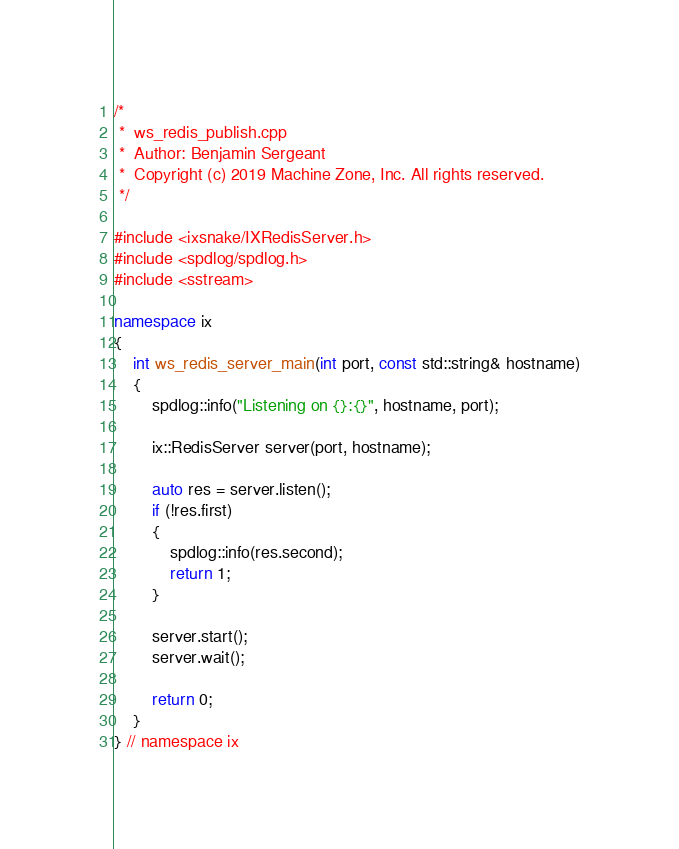<code> <loc_0><loc_0><loc_500><loc_500><_C++_>/*
 *  ws_redis_publish.cpp
 *  Author: Benjamin Sergeant
 *  Copyright (c) 2019 Machine Zone, Inc. All rights reserved.
 */

#include <ixsnake/IXRedisServer.h>
#include <spdlog/spdlog.h>
#include <sstream>

namespace ix
{
    int ws_redis_server_main(int port, const std::string& hostname)
    {
        spdlog::info("Listening on {}:{}", hostname, port);

        ix::RedisServer server(port, hostname);

        auto res = server.listen();
        if (!res.first)
        {
            spdlog::info(res.second);
            return 1;
        }

        server.start();
        server.wait();

        return 0;
    }
} // namespace ix
</code> 